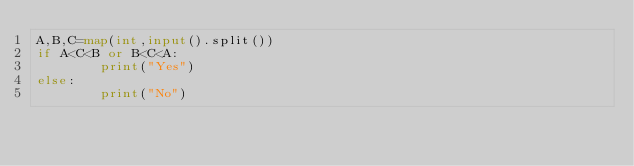<code> <loc_0><loc_0><loc_500><loc_500><_Python_>A,B,C=map(int,input().split())
if A<C<B or B<C<A:
        print("Yes")
else:
        print("No")</code> 